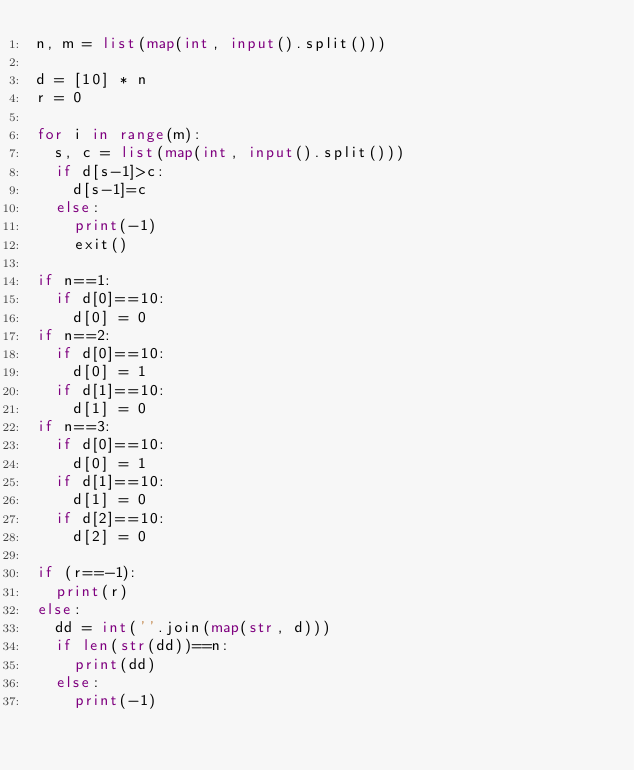Convert code to text. <code><loc_0><loc_0><loc_500><loc_500><_Python_>n, m = list(map(int, input().split()))

d = [10] * n
r = 0

for i in range(m):
  s, c = list(map(int, input().split()))
  if d[s-1]>c:
    d[s-1]=c
  else:
    print(-1)
    exit()

if n==1:
  if d[0]==10:
    d[0] = 0
if n==2:
  if d[0]==10:
    d[0] = 1
  if d[1]==10:
    d[1] = 0
if n==3:
  if d[0]==10:
    d[0] = 1
  if d[1]==10:
    d[1] = 0
  if d[2]==10:
    d[2] = 0
        
if (r==-1):
  print(r)
else:
  dd = int(''.join(map(str, d)))
  if len(str(dd))==n:
    print(dd)
  else:
    print(-1)
</code> 